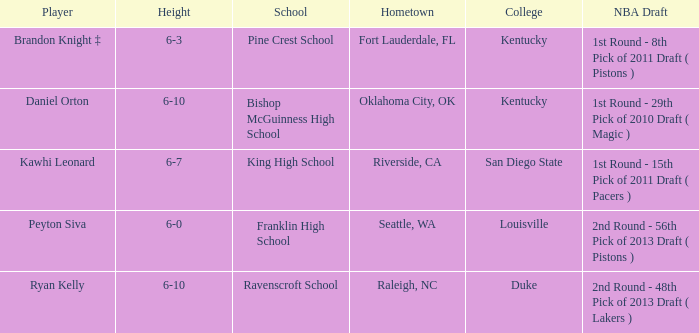Which school is in Riverside, CA? King High School. 